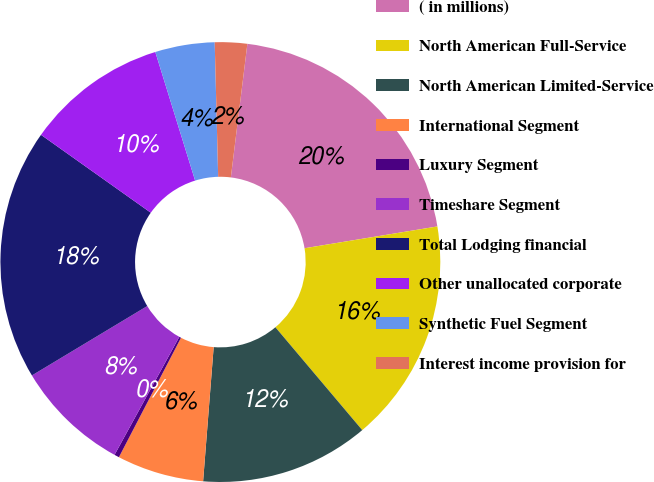Convert chart to OTSL. <chart><loc_0><loc_0><loc_500><loc_500><pie_chart><fcel>( in millions)<fcel>North American Full-Service<fcel>North American Limited-Service<fcel>International Segment<fcel>Luxury Segment<fcel>Timeshare Segment<fcel>Total Lodging financial<fcel>Other unallocated corporate<fcel>Synthetic Fuel Segment<fcel>Interest income provision for<nl><fcel>20.45%<fcel>16.43%<fcel>12.41%<fcel>6.38%<fcel>0.36%<fcel>8.39%<fcel>18.44%<fcel>10.4%<fcel>4.37%<fcel>2.37%<nl></chart> 